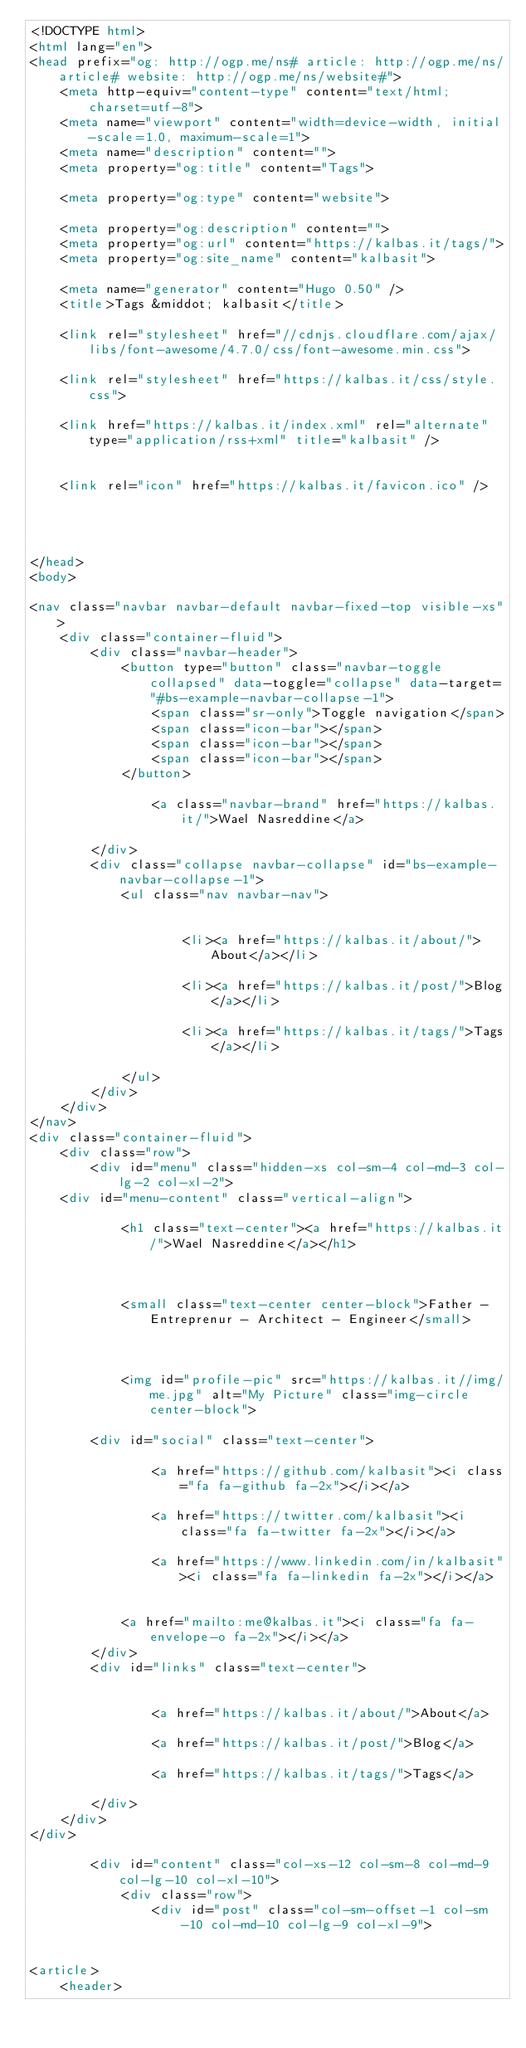<code> <loc_0><loc_0><loc_500><loc_500><_HTML_><!DOCTYPE html>
<html lang="en">
<head prefix="og: http://ogp.me/ns# article: http://ogp.me/ns/article# website: http://ogp.me/ns/website#">
    <meta http-equiv="content-type" content="text/html; charset=utf-8">
    <meta name="viewport" content="width=device-width, initial-scale=1.0, maximum-scale=1">
    <meta name="description" content="">
    <meta property="og:title" content="Tags">
    
    <meta property="og:type" content="website">
    
    <meta property="og:description" content="">
    <meta property="og:url" content="https://kalbas.it/tags/">
    <meta property="og:site_name" content="kalbasit">
    
    <meta name="generator" content="Hugo 0.50" />
    <title>Tags &middot; kalbasit</title>
    
    <link rel="stylesheet" href="//cdnjs.cloudflare.com/ajax/libs/font-awesome/4.7.0/css/font-awesome.min.css">
    
    <link rel="stylesheet" href="https://kalbas.it/css/style.css">
    
    <link href="https://kalbas.it/index.xml" rel="alternate" type="application/rss+xml" title="kalbasit" />
    
    
    <link rel="icon" href="https://kalbas.it/favicon.ico" />
    

    
    
</head>
<body>

<nav class="navbar navbar-default navbar-fixed-top visible-xs">
	<div class="container-fluid">
		<div class="navbar-header">
			<button type="button" class="navbar-toggle collapsed" data-toggle="collapse" data-target="#bs-example-navbar-collapse-1">
				<span class="sr-only">Toggle navigation</span>
				<span class="icon-bar"></span>
				<span class="icon-bar"></span>
				<span class="icon-bar"></span>
			</button>
			
				<a class="navbar-brand" href="https://kalbas.it/">Wael Nasreddine</a>
			
		</div>
		<div class="collapse navbar-collapse" id="bs-example-navbar-collapse-1">
			<ul class="nav navbar-nav">
				
				
					<li><a href="https://kalbas.it/about/">About</a></li>
				
					<li><a href="https://kalbas.it/post/">Blog</a></li>
				
					<li><a href="https://kalbas.it/tags/">Tags</a></li>
				
			</ul>
		</div>
	</div>
</nav>
<div class="container-fluid">
	<div class="row">
		<div id="menu" class="hidden-xs col-sm-4 col-md-3 col-lg-2 col-xl-2">
	<div id="menu-content" class="vertical-align">
		
			<h1 class="text-center"><a href="https://kalbas.it/">Wael Nasreddine</a></h1>
		

		
			<small class="text-center center-block">Father - Entreprenur - Architect - Engineer</small>
		

		
			<img id="profile-pic" src="https://kalbas.it//img/me.jpg" alt="My Picture" class="img-circle center-block">
		
		<div id="social" class="text-center">
			
				<a href="https://github.com/kalbasit"><i class="fa fa-github fa-2x"></i></a>
			
				<a href="https://twitter.com/kalbasit"><i class="fa fa-twitter fa-2x"></i></a>
			
				<a href="https://www.linkedin.com/in/kalbasit"><i class="fa fa-linkedin fa-2x"></i></a>
			

			<a href="mailto:me@kalbas.it"><i class="fa fa-envelope-o fa-2x"></i></a>
		</div>
		<div id="links" class="text-center">
			
			
				<a href="https://kalbas.it/about/">About</a>
			
				<a href="https://kalbas.it/post/">Blog</a>
			
				<a href="https://kalbas.it/tags/">Tags</a>
			
		</div>
	</div>
</div>

		<div id="content" class="col-xs-12 col-sm-8 col-md-9 col-lg-10 col-xl-10">
			<div class="row">
				<div id="post" class="col-sm-offset-1 col-sm-10 col-md-10 col-lg-9 col-xl-9">


<article>
	<header></code> 